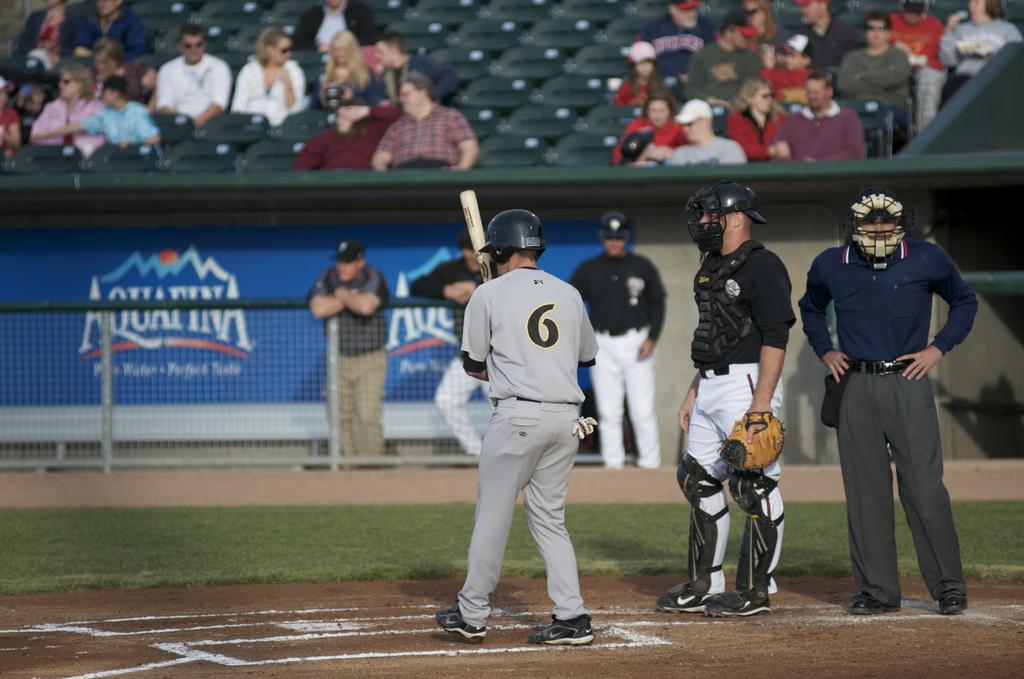What is the man jersey number?
Your answer should be compact. 6. Whata game arethey playing?
Keep it short and to the point. Answering does not require reading text in the image. 